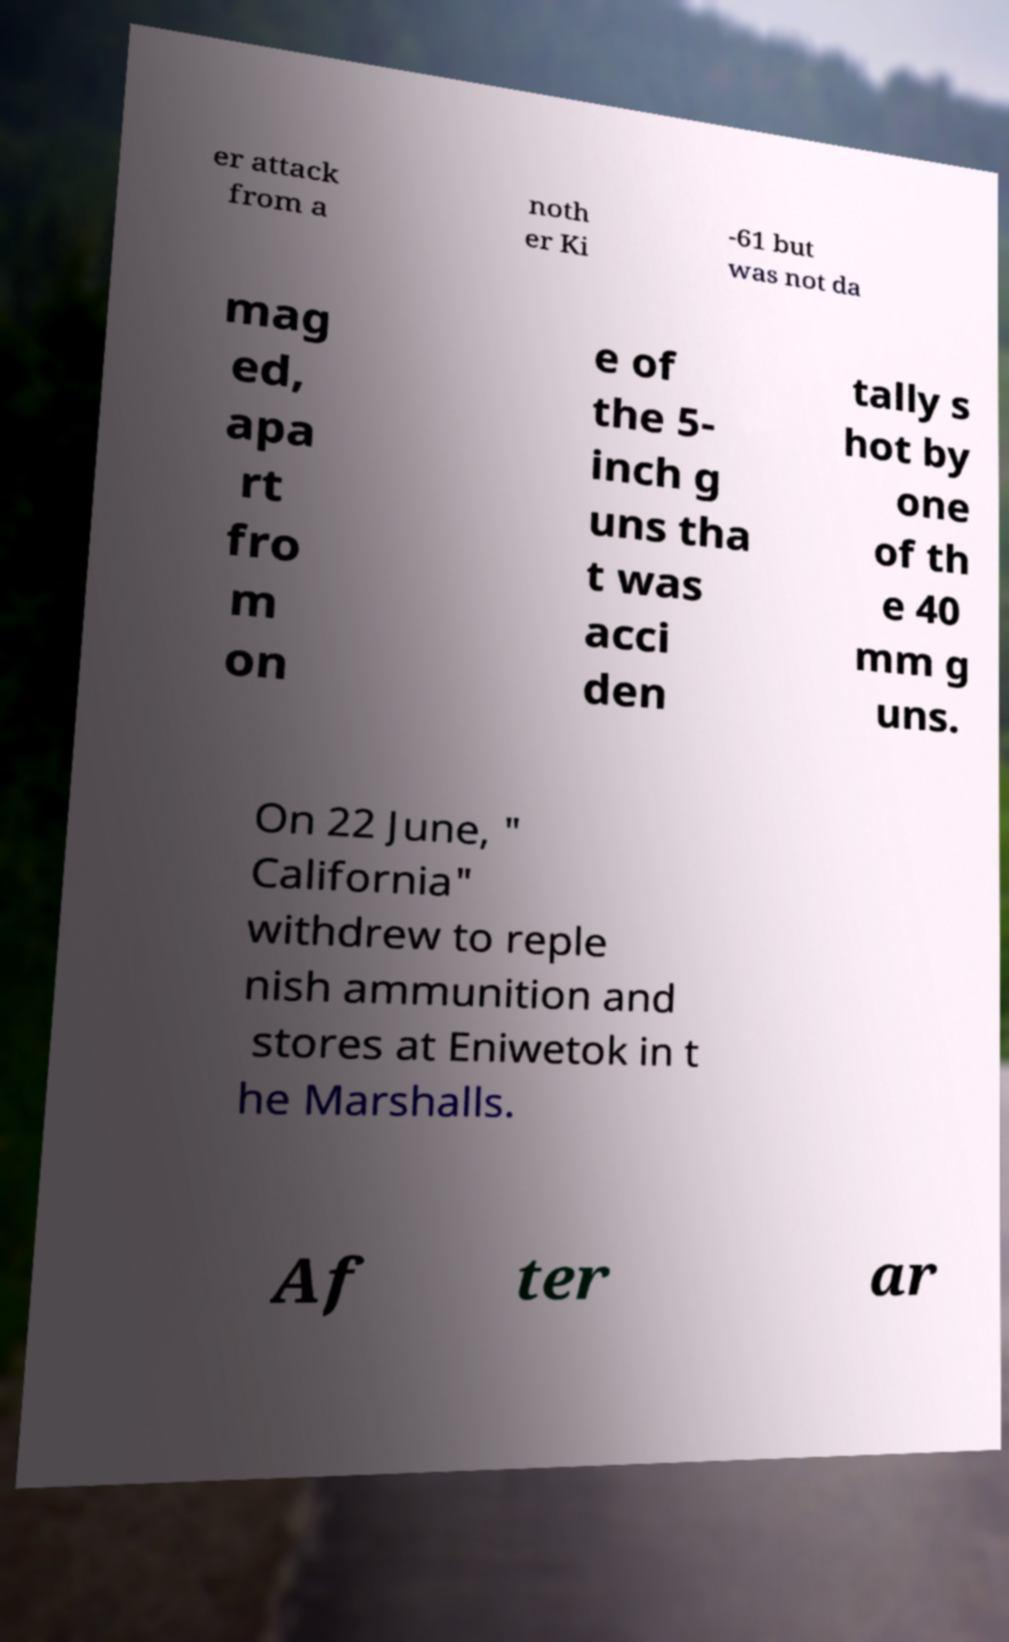Can you read and provide the text displayed in the image?This photo seems to have some interesting text. Can you extract and type it out for me? er attack from a noth er Ki -61 but was not da mag ed, apa rt fro m on e of the 5- inch g uns tha t was acci den tally s hot by one of th e 40 mm g uns. On 22 June, " California" withdrew to reple nish ammunition and stores at Eniwetok in t he Marshalls. Af ter ar 